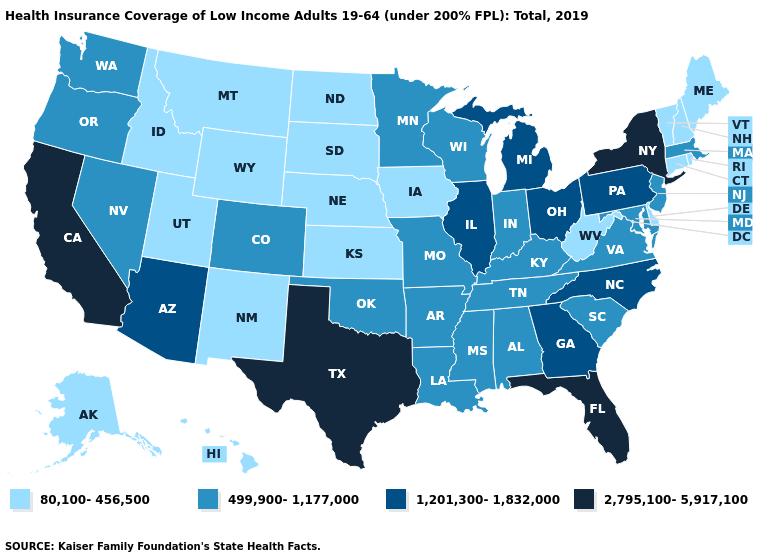Among the states that border Virginia , which have the highest value?
Be succinct. North Carolina. Name the states that have a value in the range 499,900-1,177,000?
Quick response, please. Alabama, Arkansas, Colorado, Indiana, Kentucky, Louisiana, Maryland, Massachusetts, Minnesota, Mississippi, Missouri, Nevada, New Jersey, Oklahoma, Oregon, South Carolina, Tennessee, Virginia, Washington, Wisconsin. What is the lowest value in states that border New Jersey?
Keep it brief. 80,100-456,500. Does New Jersey have the highest value in the Northeast?
Give a very brief answer. No. Among the states that border New Jersey , does Pennsylvania have the lowest value?
Concise answer only. No. Among the states that border Kentucky , does West Virginia have the lowest value?
Quick response, please. Yes. What is the value of North Dakota?
Short answer required. 80,100-456,500. Does New York have the highest value in the USA?
Write a very short answer. Yes. Does the map have missing data?
Quick response, please. No. Name the states that have a value in the range 2,795,100-5,917,100?
Answer briefly. California, Florida, New York, Texas. Does the first symbol in the legend represent the smallest category?
Quick response, please. Yes. What is the value of Utah?
Keep it brief. 80,100-456,500. Name the states that have a value in the range 80,100-456,500?
Be succinct. Alaska, Connecticut, Delaware, Hawaii, Idaho, Iowa, Kansas, Maine, Montana, Nebraska, New Hampshire, New Mexico, North Dakota, Rhode Island, South Dakota, Utah, Vermont, West Virginia, Wyoming. What is the value of Arkansas?
Be succinct. 499,900-1,177,000. 